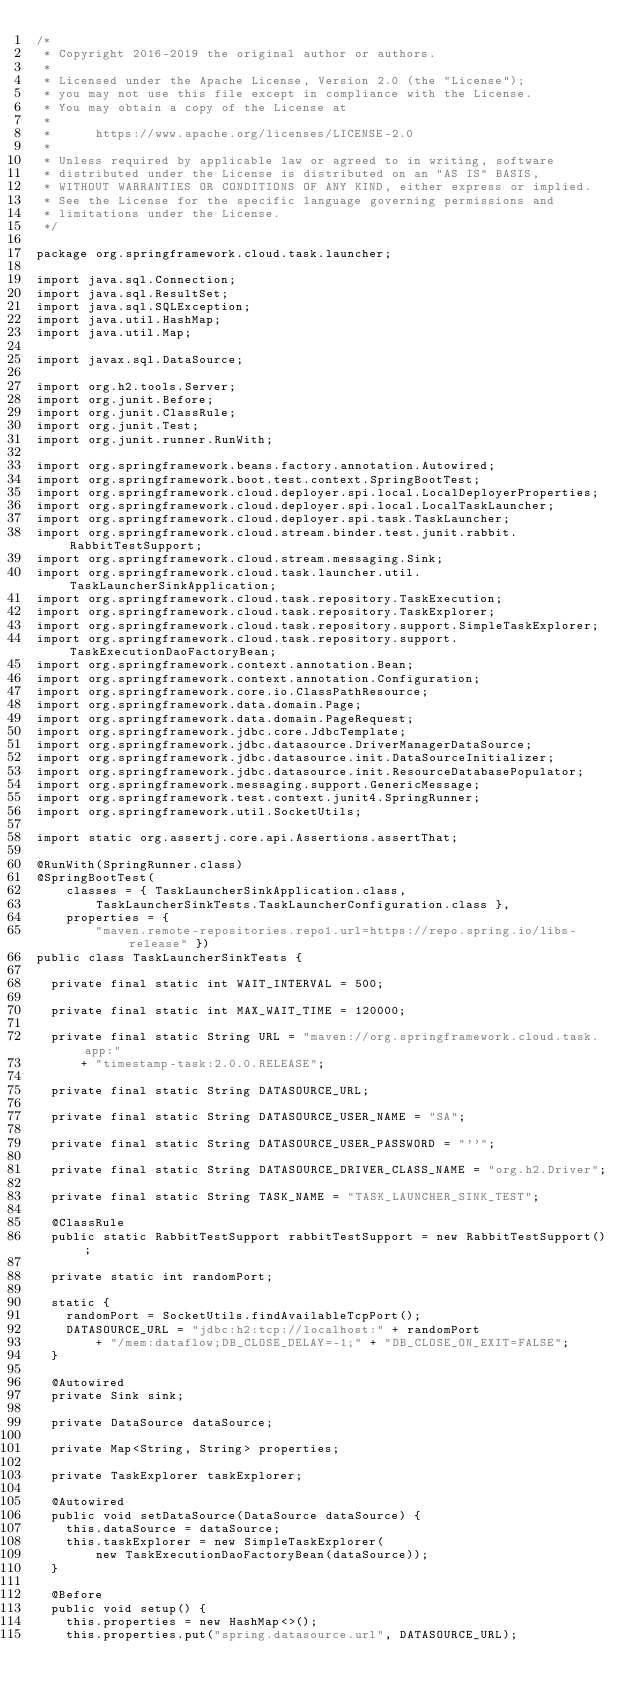<code> <loc_0><loc_0><loc_500><loc_500><_Java_>/*
 * Copyright 2016-2019 the original author or authors.
 *
 * Licensed under the Apache License, Version 2.0 (the "License");
 * you may not use this file except in compliance with the License.
 * You may obtain a copy of the License at
 *
 *      https://www.apache.org/licenses/LICENSE-2.0
 *
 * Unless required by applicable law or agreed to in writing, software
 * distributed under the License is distributed on an "AS IS" BASIS,
 * WITHOUT WARRANTIES OR CONDITIONS OF ANY KIND, either express or implied.
 * See the License for the specific language governing permissions and
 * limitations under the License.
 */

package org.springframework.cloud.task.launcher;

import java.sql.Connection;
import java.sql.ResultSet;
import java.sql.SQLException;
import java.util.HashMap;
import java.util.Map;

import javax.sql.DataSource;

import org.h2.tools.Server;
import org.junit.Before;
import org.junit.ClassRule;
import org.junit.Test;
import org.junit.runner.RunWith;

import org.springframework.beans.factory.annotation.Autowired;
import org.springframework.boot.test.context.SpringBootTest;
import org.springframework.cloud.deployer.spi.local.LocalDeployerProperties;
import org.springframework.cloud.deployer.spi.local.LocalTaskLauncher;
import org.springframework.cloud.deployer.spi.task.TaskLauncher;
import org.springframework.cloud.stream.binder.test.junit.rabbit.RabbitTestSupport;
import org.springframework.cloud.stream.messaging.Sink;
import org.springframework.cloud.task.launcher.util.TaskLauncherSinkApplication;
import org.springframework.cloud.task.repository.TaskExecution;
import org.springframework.cloud.task.repository.TaskExplorer;
import org.springframework.cloud.task.repository.support.SimpleTaskExplorer;
import org.springframework.cloud.task.repository.support.TaskExecutionDaoFactoryBean;
import org.springframework.context.annotation.Bean;
import org.springframework.context.annotation.Configuration;
import org.springframework.core.io.ClassPathResource;
import org.springframework.data.domain.Page;
import org.springframework.data.domain.PageRequest;
import org.springframework.jdbc.core.JdbcTemplate;
import org.springframework.jdbc.datasource.DriverManagerDataSource;
import org.springframework.jdbc.datasource.init.DataSourceInitializer;
import org.springframework.jdbc.datasource.init.ResourceDatabasePopulator;
import org.springframework.messaging.support.GenericMessage;
import org.springframework.test.context.junit4.SpringRunner;
import org.springframework.util.SocketUtils;

import static org.assertj.core.api.Assertions.assertThat;

@RunWith(SpringRunner.class)
@SpringBootTest(
		classes = { TaskLauncherSinkApplication.class,
				TaskLauncherSinkTests.TaskLauncherConfiguration.class },
		properties = {
				"maven.remote-repositories.repo1.url=https://repo.spring.io/libs-release" })
public class TaskLauncherSinkTests {

	private final static int WAIT_INTERVAL = 500;

	private final static int MAX_WAIT_TIME = 120000;

	private final static String URL = "maven://org.springframework.cloud.task.app:"
			+ "timestamp-task:2.0.0.RELEASE";

	private final static String DATASOURCE_URL;

	private final static String DATASOURCE_USER_NAME = "SA";

	private final static String DATASOURCE_USER_PASSWORD = "''";

	private final static String DATASOURCE_DRIVER_CLASS_NAME = "org.h2.Driver";

	private final static String TASK_NAME = "TASK_LAUNCHER_SINK_TEST";

	@ClassRule
	public static RabbitTestSupport rabbitTestSupport = new RabbitTestSupport();

	private static int randomPort;

	static {
		randomPort = SocketUtils.findAvailableTcpPort();
		DATASOURCE_URL = "jdbc:h2:tcp://localhost:" + randomPort
				+ "/mem:dataflow;DB_CLOSE_DELAY=-1;" + "DB_CLOSE_ON_EXIT=FALSE";
	}

	@Autowired
	private Sink sink;

	private DataSource dataSource;

	private Map<String, String> properties;

	private TaskExplorer taskExplorer;

	@Autowired
	public void setDataSource(DataSource dataSource) {
		this.dataSource = dataSource;
		this.taskExplorer = new SimpleTaskExplorer(
				new TaskExecutionDaoFactoryBean(dataSource));
	}

	@Before
	public void setup() {
		this.properties = new HashMap<>();
		this.properties.put("spring.datasource.url", DATASOURCE_URL);</code> 